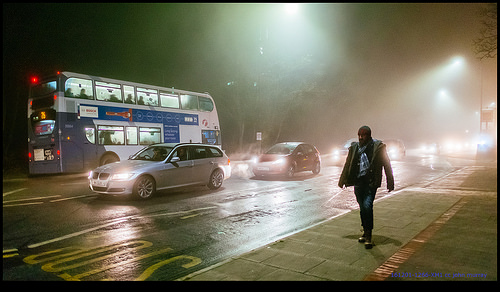<image>
Is there a light above the man? Yes. The light is positioned above the man in the vertical space, higher up in the scene. 